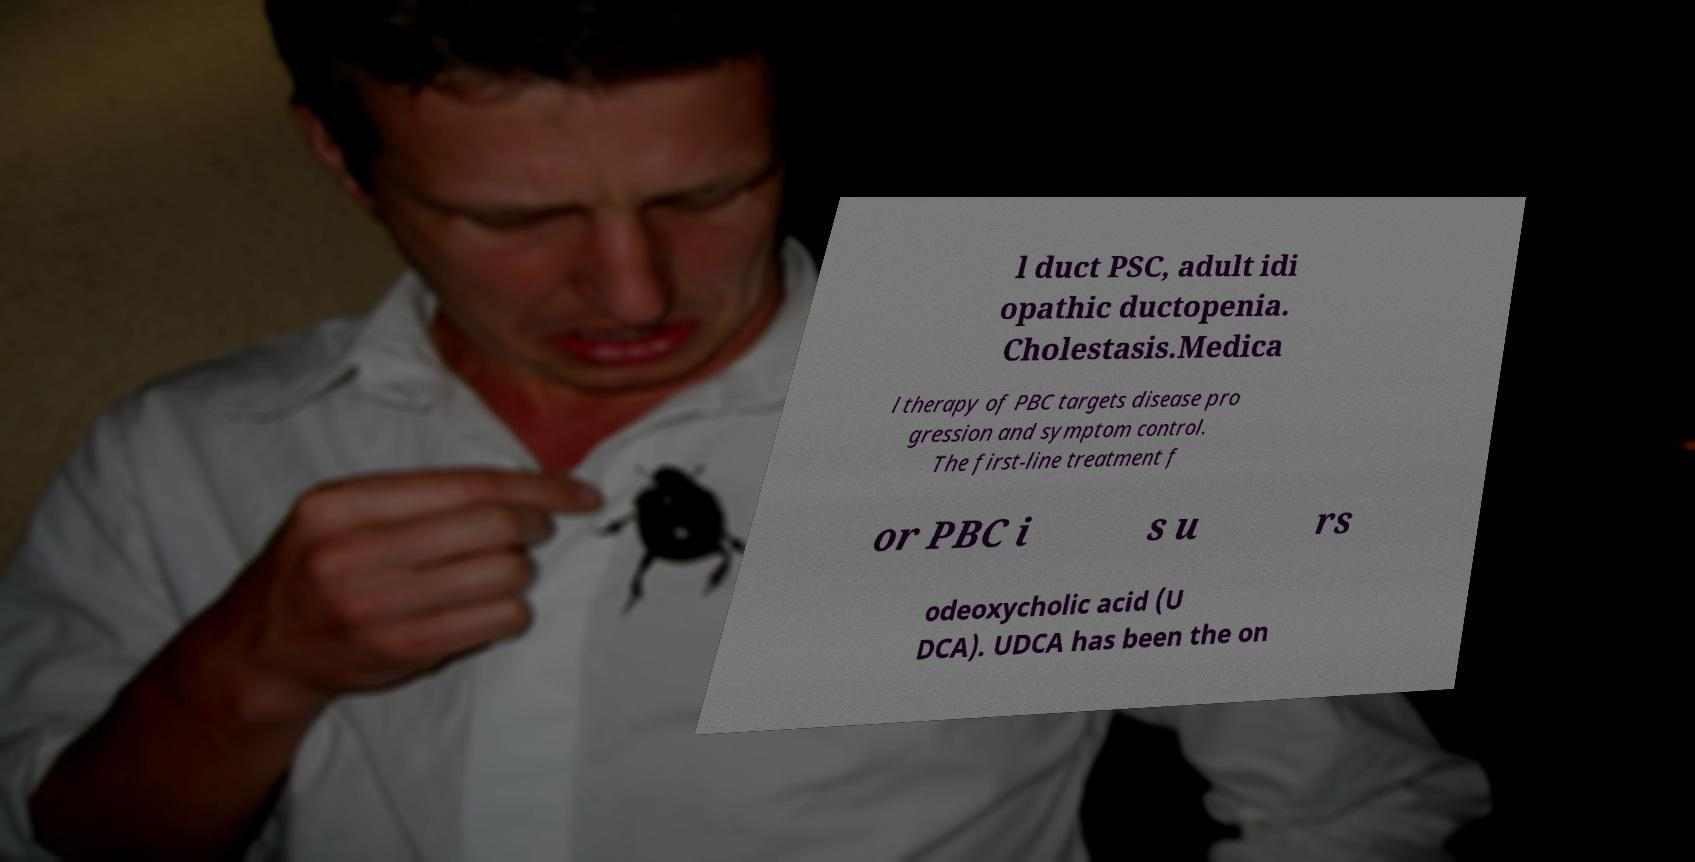For documentation purposes, I need the text within this image transcribed. Could you provide that? l duct PSC, adult idi opathic ductopenia. Cholestasis.Medica l therapy of PBC targets disease pro gression and symptom control. The first-line treatment f or PBC i s u rs odeoxycholic acid (U DCA). UDCA has been the on 